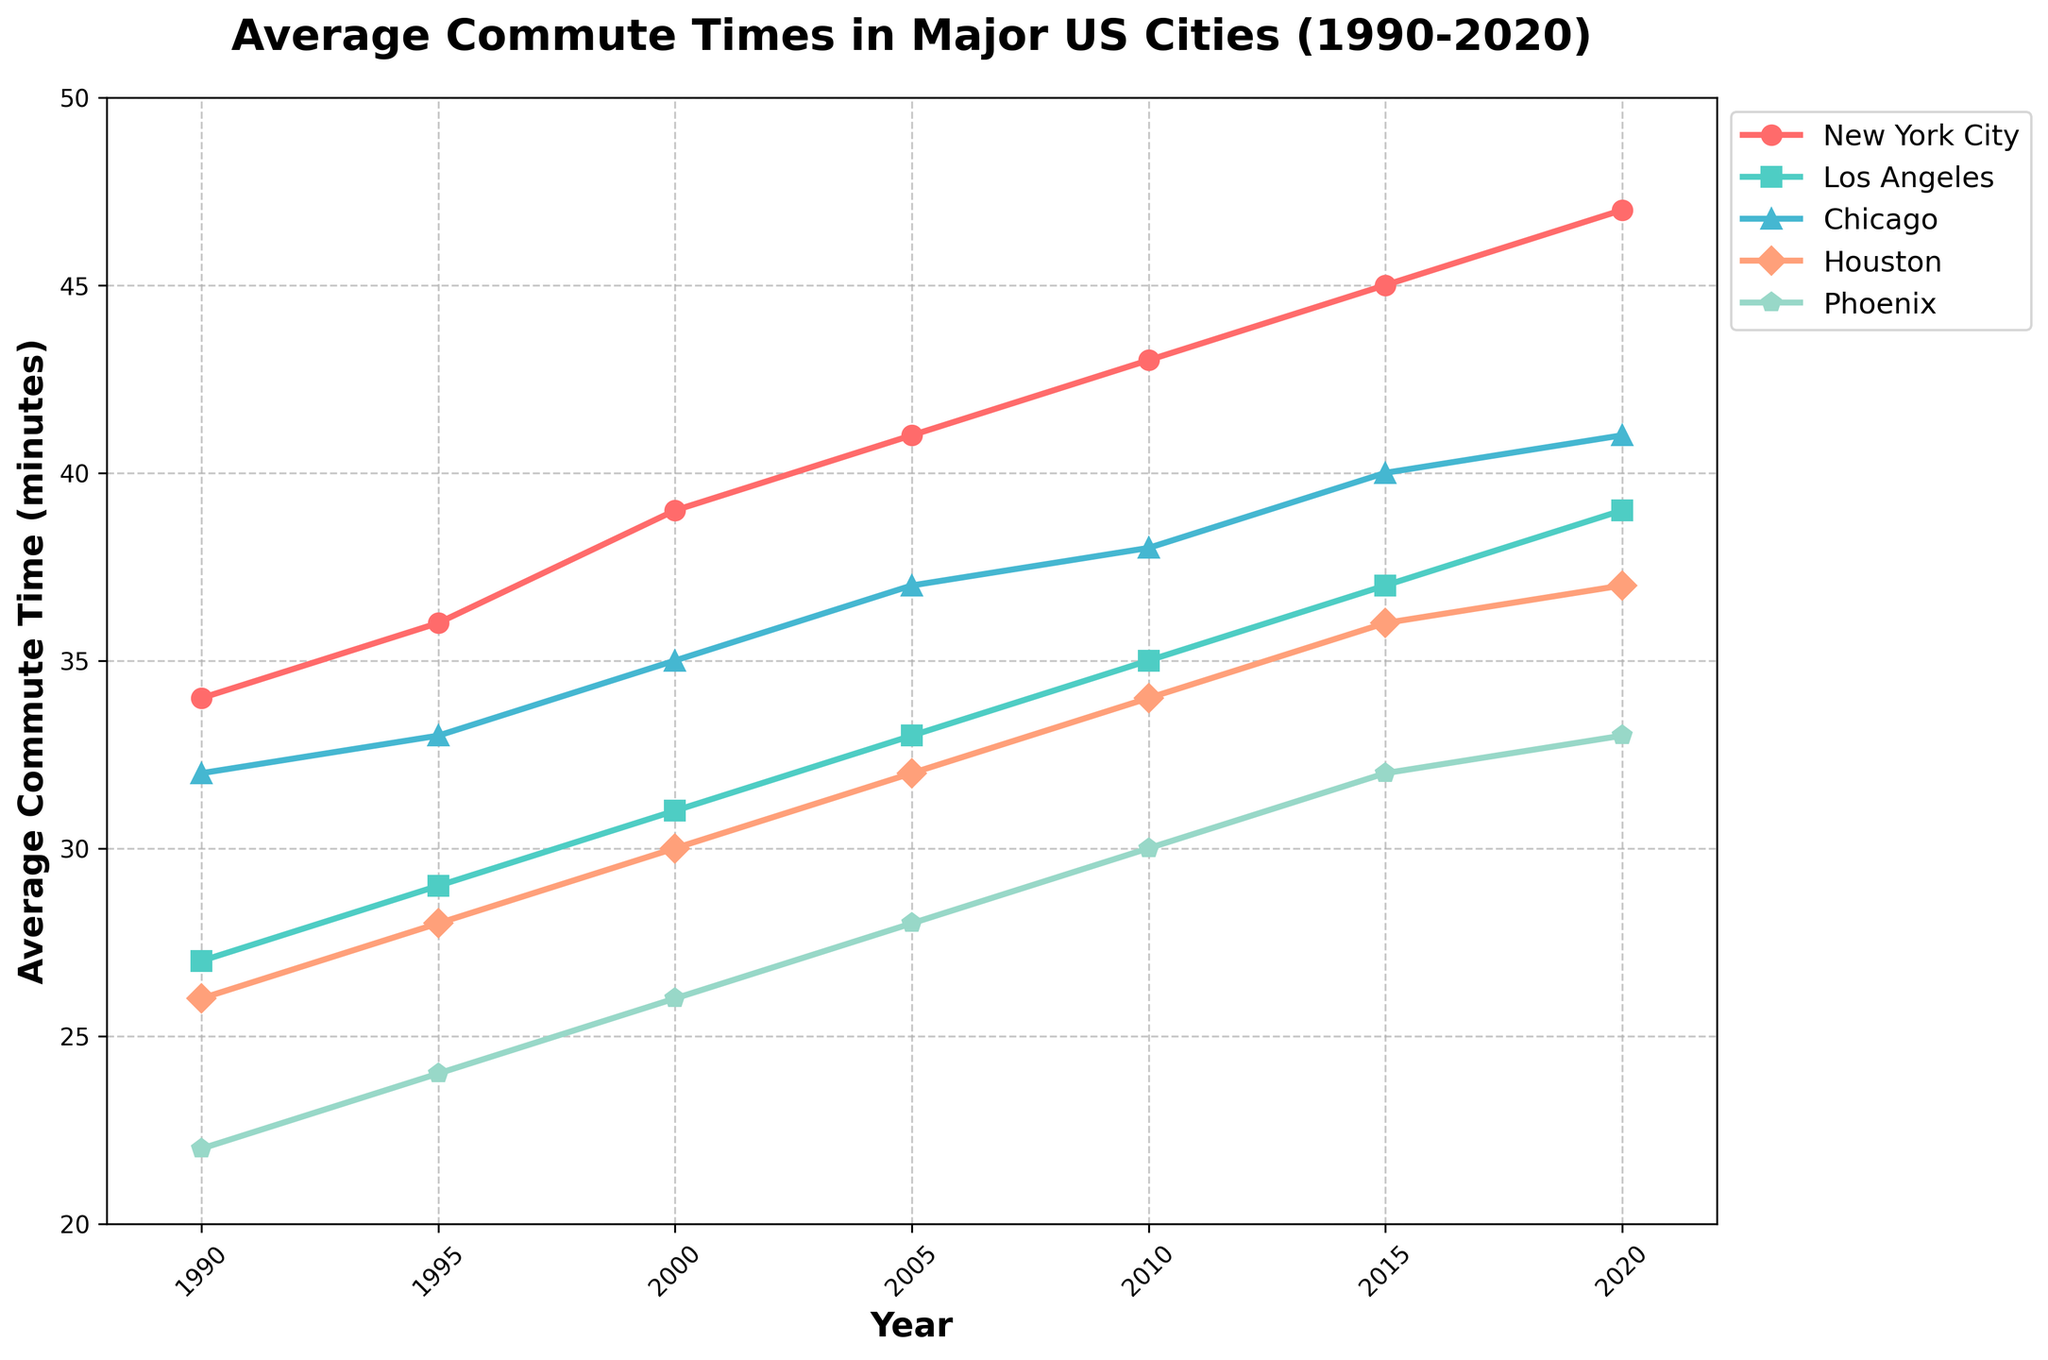Which city had the highest average commute time in 2020? Look at the data points for the year 2020 and compare the average commute times for New York City, Los Angeles, Chicago, Houston, and Phoenix. The highest value is for New York City.
Answer: New York City Which city showed the greatest increase in average commute time from 1990 to 2020? Calculate the difference in commute time between 1990 and 2020 for each city. The city with the greatest difference is New York City (47 - 34 = 13 minutes).
Answer: New York City What is the average commute time trend for New York City from 1990 to 2020? Observe the trend line for New York City. The commute time consistently increases over each period: 34 (1990), 36 (1995), 39 (2000), 41 (2005), 43 (2010), 45 (2015), 47 (2020).
Answer: Increasing By how many minutes did the average commute time in Phoenix change from 1990 to 2020? Subtract the 1990 average commute time for Phoenix from the 2020 average commute time: 33 (2020) - 22 (1990) = 11 minutes.
Answer: 11 minutes Which two cities had the closest average commute times in 2020? Compare the 2020 commute times for all cities. Chicago (41) and Houston (37) are closer compared to others but not the closest. The closest are Los Angeles (39) and Houston (37) with a difference of only 2 minutes.
Answer: Los Angeles and Houston Which city had the smallest increase in commute times over the 30-year period? Calculate the increase in commute times from 1990 to 2020 for each city and find the smallest difference. Phoenix increased from 22 to 33 minutes, i.e., an increase of 11 minutes, which is the smallest among all cities.
Answer: Phoenix Between which years did Chicago experience the largest increase in average commute time? Evaluate the differences in commute times between consecutive years for Chicago. The largest increase is between 1995 (33) and 2000 (35), a difference of 2 minutes.
Answer: 1995 to 2000 What is the combined average commute time for all five cities in 2020? Sum the 2020 average commute times for New York City (47), Los Angeles (39), Chicago (41), Houston (37), and Phoenix (33): 47 + 39 + 41 + 37 + 33 = 197 minutes.
Answer: 197 minutes 